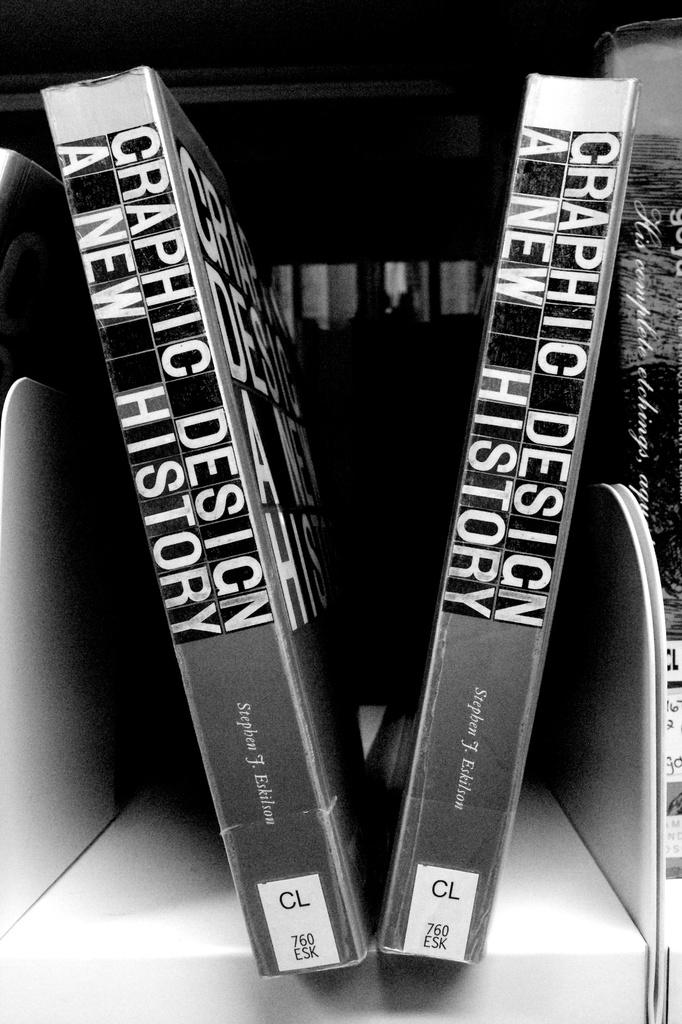What is the color scheme of the image? The image is black and white. How many books are visible in the image? There are three books in the image. Where are the books located in the image? The books are on a shelf. What type of bun is being used as a bookmark in the image? There is no bun present in the image, and the books do not have any visible bookmarks. 